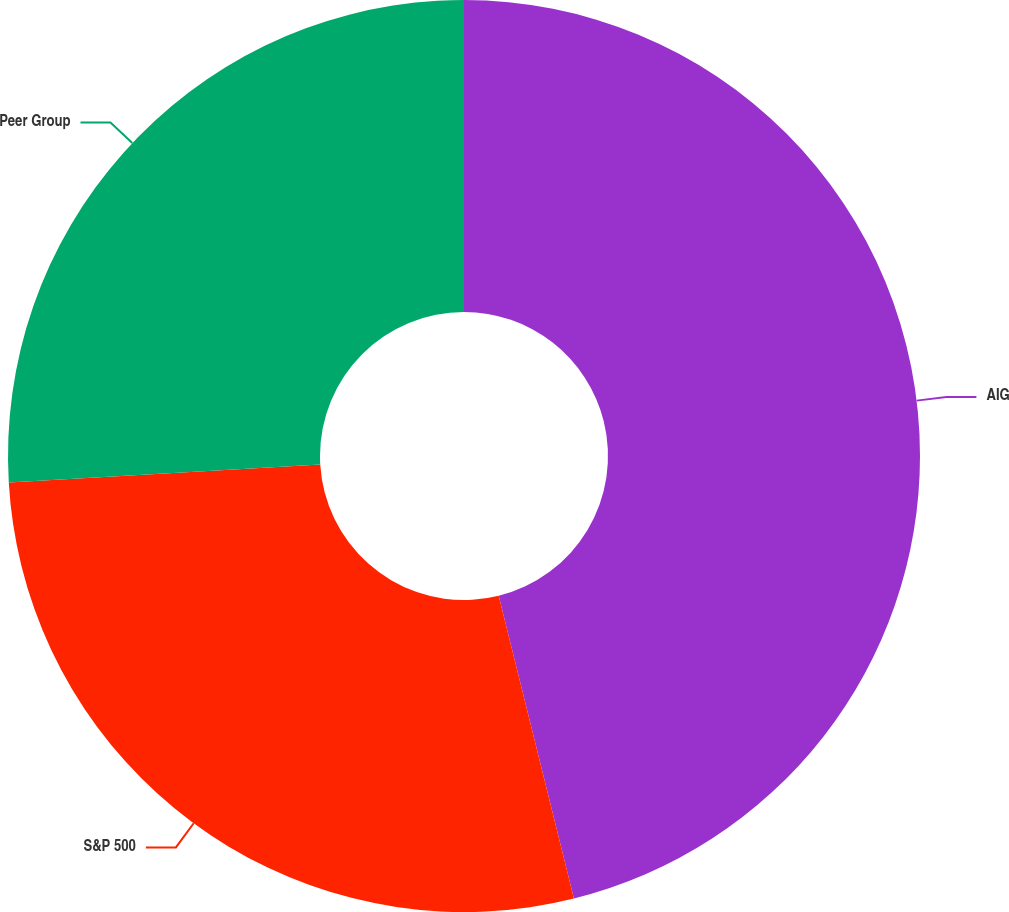Convert chart to OTSL. <chart><loc_0><loc_0><loc_500><loc_500><pie_chart><fcel>AIG<fcel>S&P 500<fcel>Peer Group<nl><fcel>46.13%<fcel>27.95%<fcel>25.93%<nl></chart> 